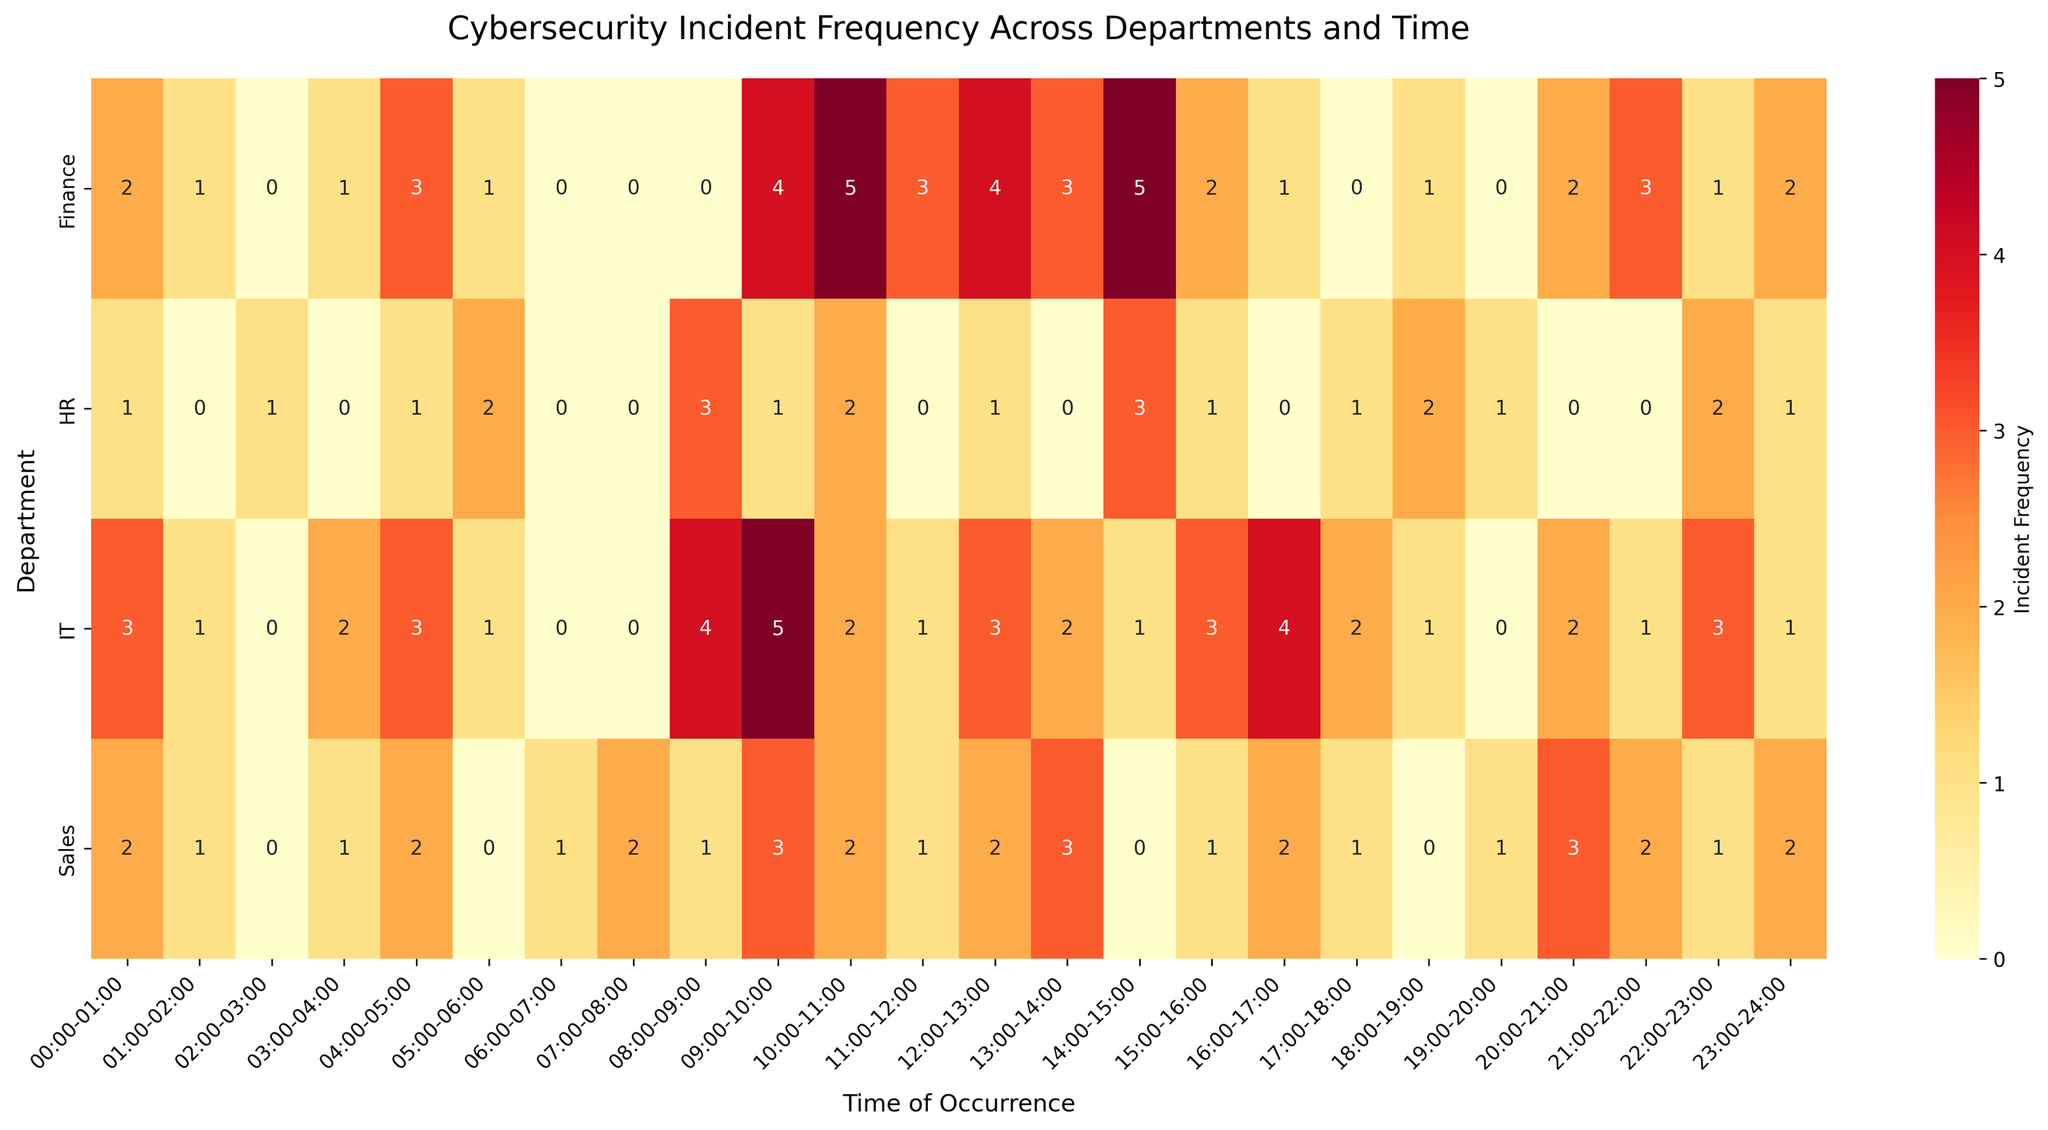What's the title of the figure? The title is the main heading displayed at the top of the figure, indicating what the figure represents. You can find this text right above the heatmap.
Answer: Cybersecurity Incident Frequency Across Departments and Time Which department has the highest frequency of incidents at 09:00-10:00? To find the department with the highest frequency of incidents at 09:00-10:00, look at the column labeled '09:00-10:00' and compare the values under each department.
Answer: IT What is the total incident frequency for the HR department? To get the total incident frequency for the HR department, sum up all the values in the row corresponding to 'HR'.
Answer: 27 During which time range does the Sales department have the highest incident frequency? Examine the row for the Sales department and identify the time range column with the highest value.
Answer: 20:00-21:00 How many time slots have zero incidents reported across all departments? Look through the heatmap and count the number of cells with a '0' value across all departments.
Answer: 13 Compare the incident frequency of IT and Finance departments during 10:00-11:00. Which department has more incidents? Check the values in the '10:00-11:00' column for both IT and Finance and compare them to see which is higher.
Answer: Finance What is the average incident frequency for the Finance department during 14:00-18:00? Sum the incident frequencies for Finance between 14:00 and 18:00 (14:00-15:00, 15:00-16:00, 16:00-17:00, 17:00-18:00) and divide by 4.
Answer: 2.25 Which time range has the lowest incident frequency for the IT department? Check the IT row and identify the time range column with the lowest value. If there are multiple time slots with the same frequency, pick any one of them.
Answer: 02:00-03:00 What is the incident frequency difference between the Finance and Sales departments at 04:00-05:00? Look at the '04:00-05:00' column for both Finance and Sales and subtract the Sales value from the Finance value.
Answer: 1 